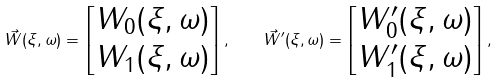<formula> <loc_0><loc_0><loc_500><loc_500>\vec { W } ( \xi , \omega ) = \begin{bmatrix} W _ { 0 } ( \xi , \omega ) \\ W _ { 1 } ( \xi , \omega ) \end{bmatrix} , \quad \vec { W } ^ { \prime } ( \xi , \omega ) = \begin{bmatrix} W ^ { \prime } _ { 0 } ( \xi , \omega ) \\ W ^ { \prime } _ { 1 } ( \xi , \omega ) \end{bmatrix} ,</formula> 